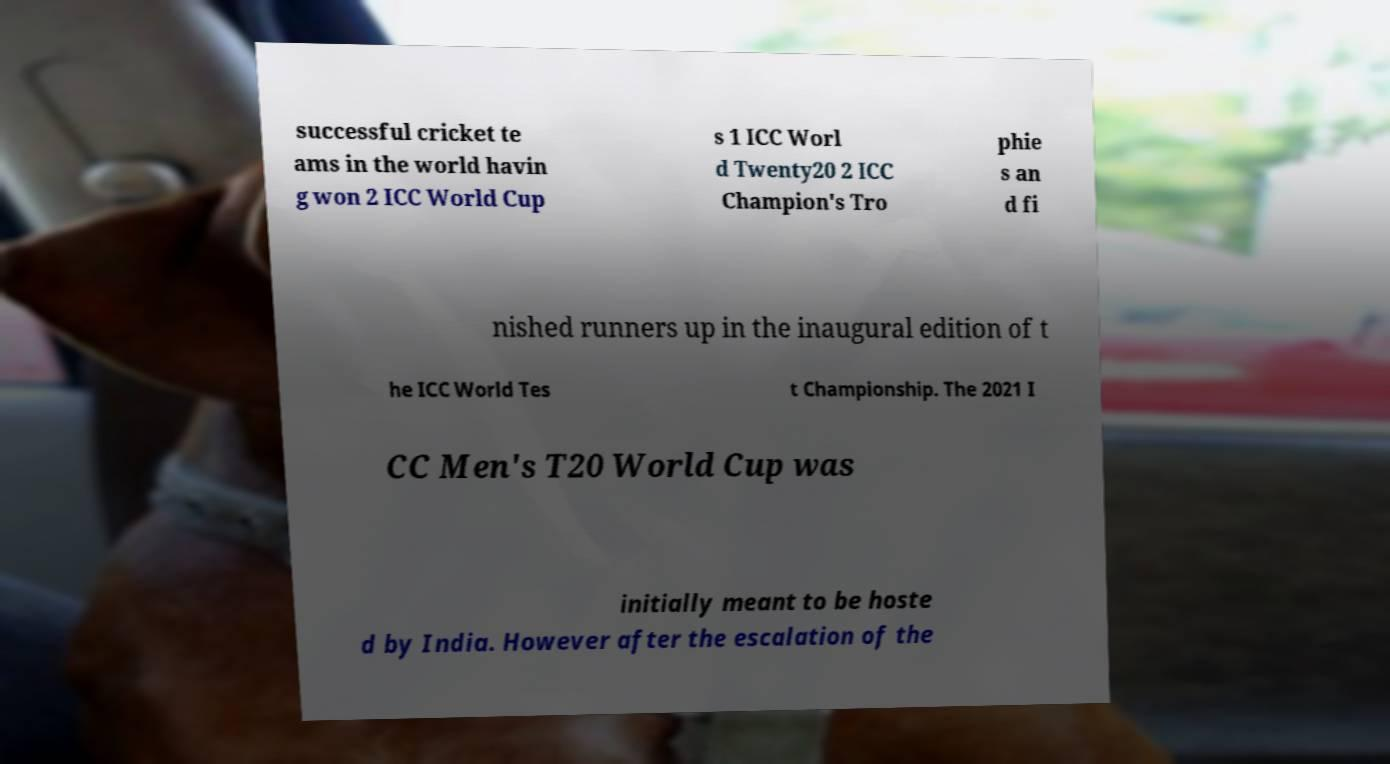What messages or text are displayed in this image? I need them in a readable, typed format. successful cricket te ams in the world havin g won 2 ICC World Cup s 1 ICC Worl d Twenty20 2 ICC Champion's Tro phie s an d fi nished runners up in the inaugural edition of t he ICC World Tes t Championship. The 2021 I CC Men's T20 World Cup was initially meant to be hoste d by India. However after the escalation of the 